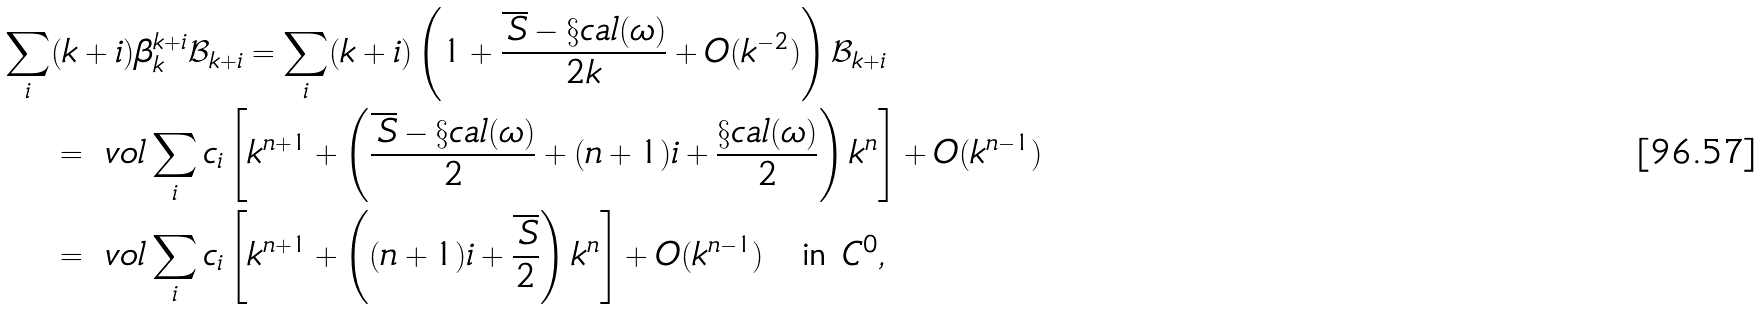<formula> <loc_0><loc_0><loc_500><loc_500>\sum _ { i } & ( k + i ) \beta _ { k } ^ { k + i } \mathcal { B } _ { k + i } = \sum _ { i } ( k + i ) \left ( 1 + \frac { \overline { \, S } - \S c a l ( \omega ) } { 2 k } + O ( k ^ { - 2 } ) \right ) \mathcal { B } _ { k + i } \\ & = \ v o l \sum _ { i } c _ { i } \left [ k ^ { n + 1 } + \left ( \frac { \overline { \, S } - \S c a l ( \omega ) } { 2 } + ( n + 1 ) i + \frac { \S c a l ( \omega ) } { 2 } \right ) k ^ { n } \right ] + O ( k ^ { n - 1 } ) \\ & = \ v o l \sum _ { i } c _ { i } \left [ k ^ { n + 1 } + \left ( ( n + 1 ) i + \frac { \overline { \, S } } { 2 } \right ) k ^ { n } \right ] + O ( k ^ { n - 1 } ) \quad \text {in } C ^ { 0 } ,</formula> 